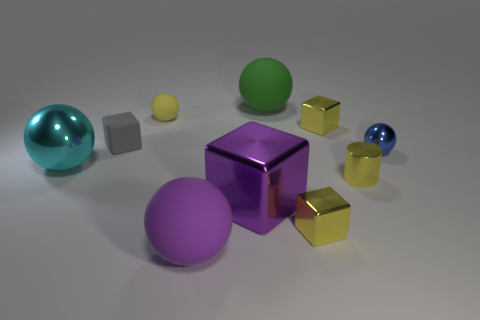Subtract all big shiny balls. How many balls are left? 4 Subtract 4 blocks. How many blocks are left? 0 Subtract all blue balls. How many balls are left? 4 Subtract all tiny green rubber cylinders. Subtract all green balls. How many objects are left? 9 Add 8 tiny yellow rubber things. How many tiny yellow rubber things are left? 9 Add 9 big metallic cubes. How many big metallic cubes exist? 10 Subtract 1 blue balls. How many objects are left? 9 Subtract all cylinders. How many objects are left? 9 Subtract all cyan cylinders. Subtract all purple spheres. How many cylinders are left? 1 Subtract all gray cylinders. How many purple blocks are left? 1 